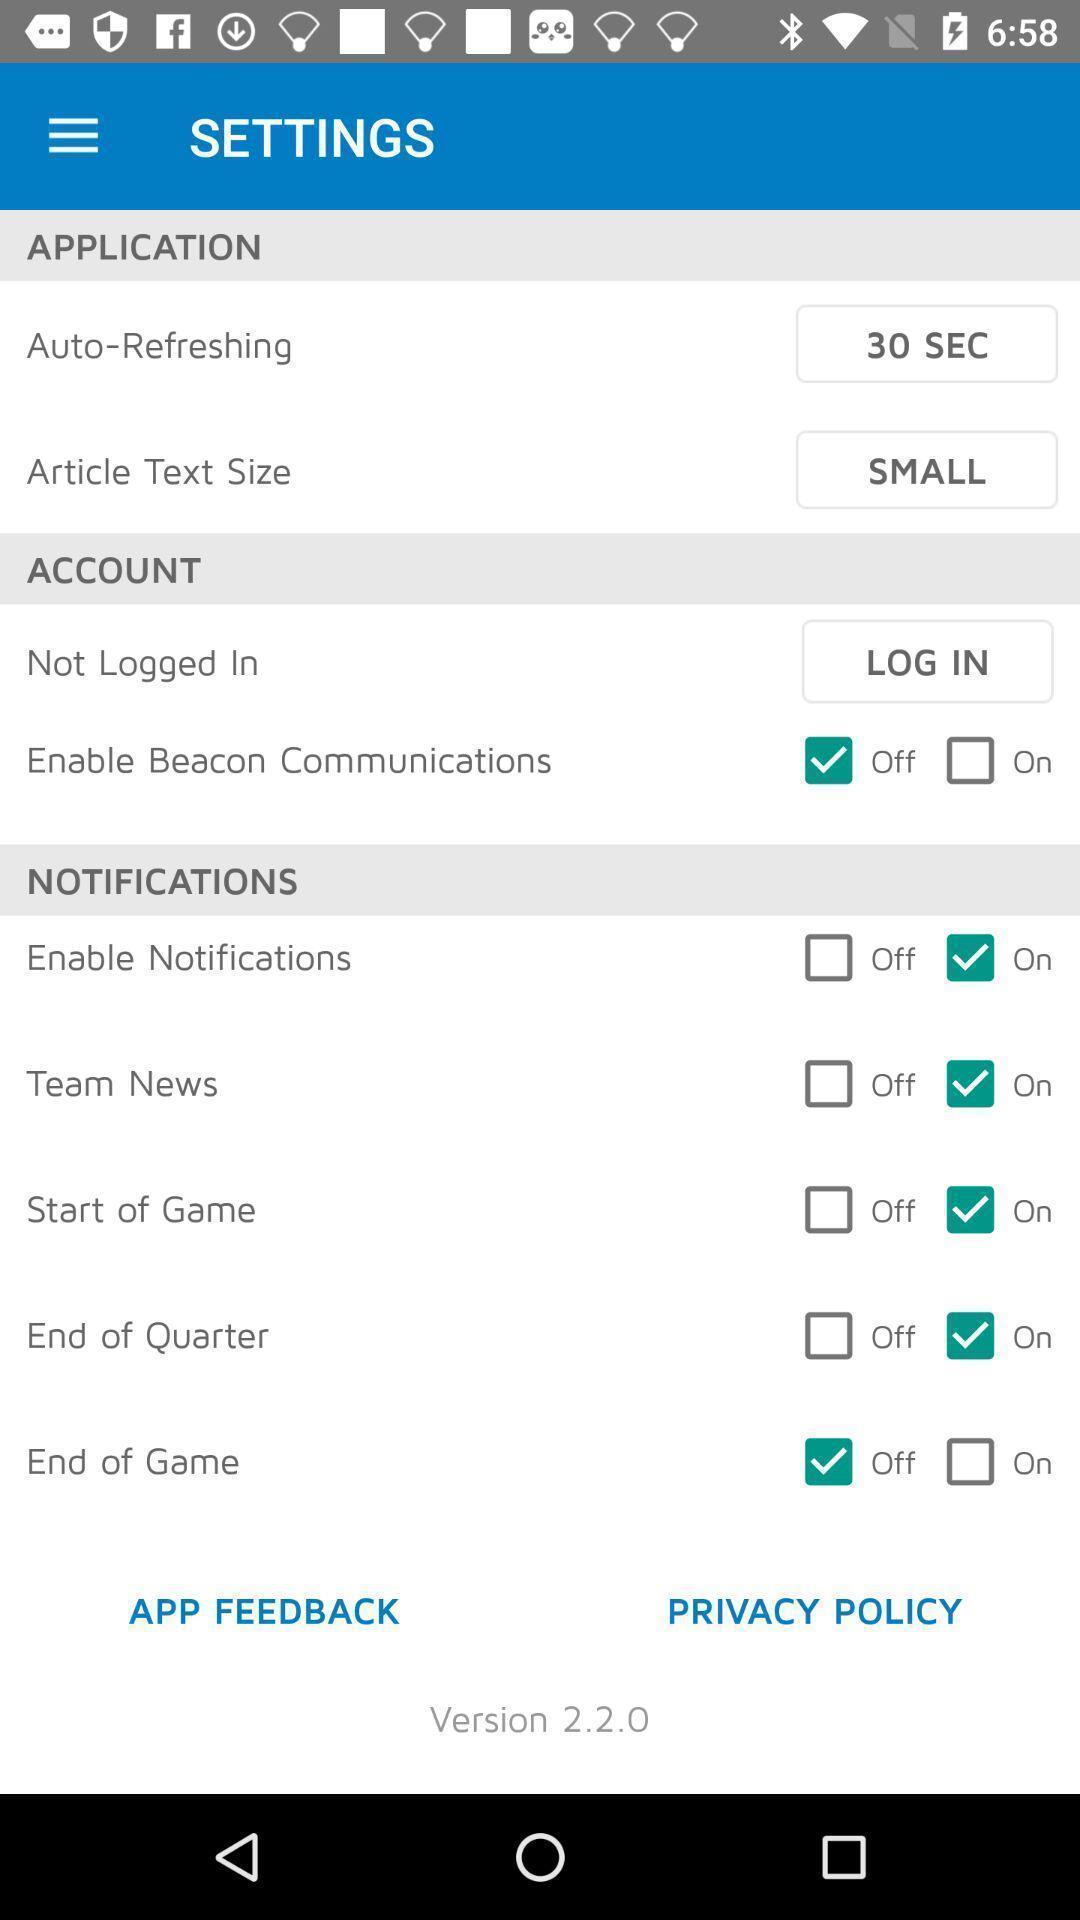What is the overall content of this screenshot? Settings page of sports application. 